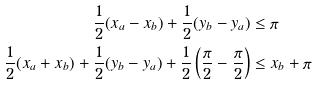Convert formula to latex. <formula><loc_0><loc_0><loc_500><loc_500>\frac { 1 } { 2 } ( x _ { a } - x _ { b } ) + \frac { 1 } { 2 } ( y _ { b } - y _ { a } ) & \leq \pi \\ \frac { 1 } { 2 } ( x _ { a } + x _ { b } ) + \frac { 1 } { 2 } ( y _ { b } - y _ { a } ) + \frac { 1 } { 2 } \left ( \frac { \pi } { 2 } - \frac { \pi } { 2 } \right ) & \leq x _ { b } + \pi</formula> 